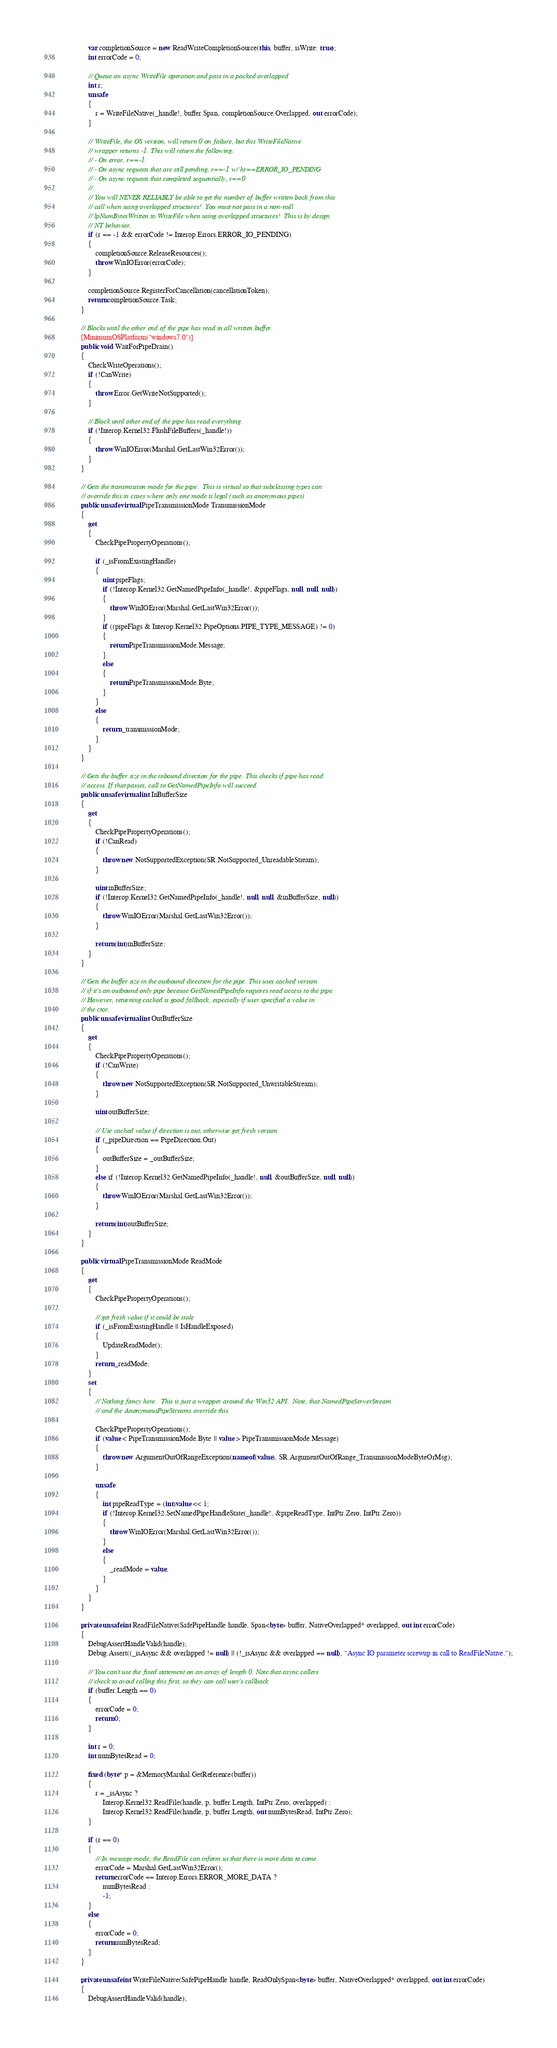<code> <loc_0><loc_0><loc_500><loc_500><_C#_>            var completionSource = new ReadWriteCompletionSource(this, buffer, isWrite: true);
            int errorCode = 0;

            // Queue an async WriteFile operation and pass in a packed overlapped
            int r;
            unsafe
            {
                r = WriteFileNative(_handle!, buffer.Span, completionSource.Overlapped, out errorCode);
            }

            // WriteFile, the OS version, will return 0 on failure, but this WriteFileNative
            // wrapper returns -1. This will return the following:
            // - On error, r==-1.
            // - On async requests that are still pending, r==-1 w/ hr==ERROR_IO_PENDING
            // - On async requests that completed sequentially, r==0
            //
            // You will NEVER RELIABLY be able to get the number of buffer written back from this
            // call when using overlapped structures!  You must not pass in a non-null
            // lpNumBytesWritten to WriteFile when using overlapped structures!  This is by design
            // NT behavior.
            if (r == -1 && errorCode != Interop.Errors.ERROR_IO_PENDING)
            {
                completionSource.ReleaseResources();
                throw WinIOError(errorCode);
            }

            completionSource.RegisterForCancellation(cancellationToken);
            return completionSource.Task;
        }

        // Blocks until the other end of the pipe has read in all written buffer.
        [MinimumOSPlatform("windows7.0")]
        public void WaitForPipeDrain()
        {
            CheckWriteOperations();
            if (!CanWrite)
            {
                throw Error.GetWriteNotSupported();
            }

            // Block until other end of the pipe has read everything.
            if (!Interop.Kernel32.FlushFileBuffers(_handle!))
            {
                throw WinIOError(Marshal.GetLastWin32Error());
            }
        }

        // Gets the transmission mode for the pipe.  This is virtual so that subclassing types can
        // override this in cases where only one mode is legal (such as anonymous pipes)
        public unsafe virtual PipeTransmissionMode TransmissionMode
        {
            get
            {
                CheckPipePropertyOperations();

                if (_isFromExistingHandle)
                {
                    uint pipeFlags;
                    if (!Interop.Kernel32.GetNamedPipeInfo(_handle!, &pipeFlags, null, null, null))
                    {
                        throw WinIOError(Marshal.GetLastWin32Error());
                    }
                    if ((pipeFlags & Interop.Kernel32.PipeOptions.PIPE_TYPE_MESSAGE) != 0)
                    {
                        return PipeTransmissionMode.Message;
                    }
                    else
                    {
                        return PipeTransmissionMode.Byte;
                    }
                }
                else
                {
                    return _transmissionMode;
                }
            }
        }

        // Gets the buffer size in the inbound direction for the pipe. This checks if pipe has read
        // access. If that passes, call to GetNamedPipeInfo will succeed.
        public unsafe virtual int InBufferSize
        {
            get
            {
                CheckPipePropertyOperations();
                if (!CanRead)
                {
                    throw new NotSupportedException(SR.NotSupported_UnreadableStream);
                }

                uint inBufferSize;
                if (!Interop.Kernel32.GetNamedPipeInfo(_handle!, null, null, &inBufferSize, null))
                {
                    throw WinIOError(Marshal.GetLastWin32Error());
                }

                return (int)inBufferSize;
            }
        }

        // Gets the buffer size in the outbound direction for the pipe. This uses cached version
        // if it's an outbound only pipe because GetNamedPipeInfo requires read access to the pipe.
        // However, returning cached is good fallback, especially if user specified a value in
        // the ctor.
        public unsafe virtual int OutBufferSize
        {
            get
            {
                CheckPipePropertyOperations();
                if (!CanWrite)
                {
                    throw new NotSupportedException(SR.NotSupported_UnwritableStream);
                }

                uint outBufferSize;

                // Use cached value if direction is out; otherwise get fresh version
                if (_pipeDirection == PipeDirection.Out)
                {
                    outBufferSize = _outBufferSize;
                }
                else if (!Interop.Kernel32.GetNamedPipeInfo(_handle!, null, &outBufferSize, null, null))
                {
                    throw WinIOError(Marshal.GetLastWin32Error());
                }

                return (int)outBufferSize;
            }
        }

        public virtual PipeTransmissionMode ReadMode
        {
            get
            {
                CheckPipePropertyOperations();

                // get fresh value if it could be stale
                if (_isFromExistingHandle || IsHandleExposed)
                {
                    UpdateReadMode();
                }
                return _readMode;
            }
            set
            {
                // Nothing fancy here.  This is just a wrapper around the Win32 API.  Note, that NamedPipeServerStream
                // and the AnonymousPipeStreams override this.

                CheckPipePropertyOperations();
                if (value < PipeTransmissionMode.Byte || value > PipeTransmissionMode.Message)
                {
                    throw new ArgumentOutOfRangeException(nameof(value), SR.ArgumentOutOfRange_TransmissionModeByteOrMsg);
                }

                unsafe
                {
                    int pipeReadType = (int)value << 1;
                    if (!Interop.Kernel32.SetNamedPipeHandleState(_handle!, &pipeReadType, IntPtr.Zero, IntPtr.Zero))
                    {
                        throw WinIOError(Marshal.GetLastWin32Error());
                    }
                    else
                    {
                        _readMode = value;
                    }
                }
            }
        }

        private unsafe int ReadFileNative(SafePipeHandle handle, Span<byte> buffer, NativeOverlapped* overlapped, out int errorCode)
        {
            DebugAssertHandleValid(handle);
            Debug.Assert((_isAsync && overlapped != null) || (!_isAsync && overlapped == null), "Async IO parameter screwup in call to ReadFileNative.");

            // You can't use the fixed statement on an array of length 0. Note that async callers
            // check to avoid calling this first, so they can call user's callback
            if (buffer.Length == 0)
            {
                errorCode = 0;
                return 0;
            }

            int r = 0;
            int numBytesRead = 0;

            fixed (byte* p = &MemoryMarshal.GetReference(buffer))
            {
                r = _isAsync ?
                    Interop.Kernel32.ReadFile(handle, p, buffer.Length, IntPtr.Zero, overlapped) :
                    Interop.Kernel32.ReadFile(handle, p, buffer.Length, out numBytesRead, IntPtr.Zero);
            }

            if (r == 0)
            {
                // In message mode, the ReadFile can inform us that there is more data to come.
                errorCode = Marshal.GetLastWin32Error();
                return errorCode == Interop.Errors.ERROR_MORE_DATA ?
                    numBytesRead :
                    -1;
            }
            else
            {
                errorCode = 0;
                return numBytesRead;
            }
        }

        private unsafe int WriteFileNative(SafePipeHandle handle, ReadOnlySpan<byte> buffer, NativeOverlapped* overlapped, out int errorCode)
        {
            DebugAssertHandleValid(handle);</code> 